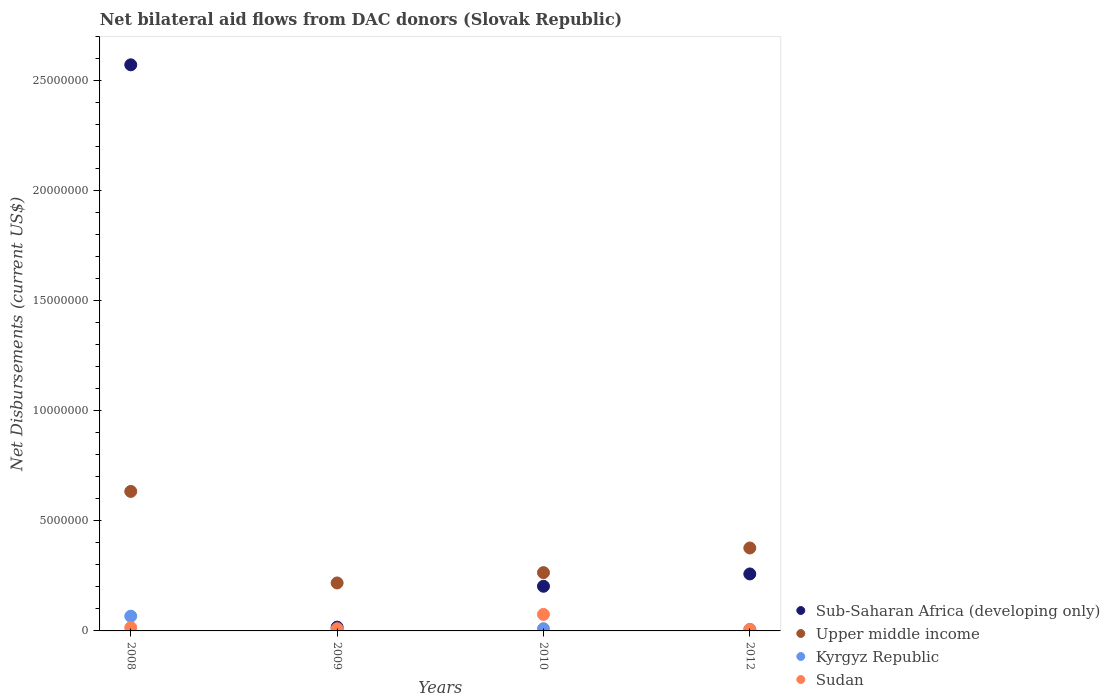What is the net bilateral aid flows in Kyrgyz Republic in 2008?
Offer a very short reply. 6.70e+05. Across all years, what is the maximum net bilateral aid flows in Kyrgyz Republic?
Ensure brevity in your answer.  6.70e+05. Across all years, what is the minimum net bilateral aid flows in Sub-Saharan Africa (developing only)?
Your answer should be compact. 1.70e+05. What is the total net bilateral aid flows in Sudan in the graph?
Offer a terse response. 1.06e+06. What is the difference between the net bilateral aid flows in Upper middle income in 2010 and that in 2012?
Provide a short and direct response. -1.12e+06. What is the difference between the net bilateral aid flows in Sudan in 2008 and the net bilateral aid flows in Sub-Saharan Africa (developing only) in 2012?
Provide a short and direct response. -2.44e+06. What is the average net bilateral aid flows in Sub-Saharan Africa (developing only) per year?
Keep it short and to the point. 7.63e+06. In the year 2008, what is the difference between the net bilateral aid flows in Sub-Saharan Africa (developing only) and net bilateral aid flows in Kyrgyz Republic?
Provide a succinct answer. 2.51e+07. What is the ratio of the net bilateral aid flows in Sudan in 2009 to that in 2010?
Make the answer very short. 0.13. Is the net bilateral aid flows in Kyrgyz Republic in 2009 less than that in 2012?
Provide a succinct answer. No. Is the difference between the net bilateral aid flows in Sub-Saharan Africa (developing only) in 2010 and 2012 greater than the difference between the net bilateral aid flows in Kyrgyz Republic in 2010 and 2012?
Your response must be concise. No. What is the difference between the highest and the second highest net bilateral aid flows in Kyrgyz Republic?
Give a very brief answer. 5.70e+05. What is the difference between the highest and the lowest net bilateral aid flows in Sudan?
Your response must be concise. 6.90e+05. Is it the case that in every year, the sum of the net bilateral aid flows in Sub-Saharan Africa (developing only) and net bilateral aid flows in Sudan  is greater than the sum of net bilateral aid flows in Kyrgyz Republic and net bilateral aid flows in Upper middle income?
Your response must be concise. Yes. Is it the case that in every year, the sum of the net bilateral aid flows in Upper middle income and net bilateral aid flows in Sudan  is greater than the net bilateral aid flows in Kyrgyz Republic?
Your response must be concise. Yes. Is the net bilateral aid flows in Sudan strictly less than the net bilateral aid flows in Sub-Saharan Africa (developing only) over the years?
Ensure brevity in your answer.  Yes. How many dotlines are there?
Keep it short and to the point. 4. How many years are there in the graph?
Offer a very short reply. 4. Are the values on the major ticks of Y-axis written in scientific E-notation?
Offer a terse response. No. Does the graph contain any zero values?
Your answer should be compact. No. Where does the legend appear in the graph?
Your answer should be very brief. Bottom right. How are the legend labels stacked?
Offer a terse response. Vertical. What is the title of the graph?
Offer a very short reply. Net bilateral aid flows from DAC donors (Slovak Republic). Does "Upper middle income" appear as one of the legend labels in the graph?
Make the answer very short. Yes. What is the label or title of the X-axis?
Provide a succinct answer. Years. What is the label or title of the Y-axis?
Ensure brevity in your answer.  Net Disbursements (current US$). What is the Net Disbursements (current US$) in Sub-Saharan Africa (developing only) in 2008?
Provide a succinct answer. 2.57e+07. What is the Net Disbursements (current US$) in Upper middle income in 2008?
Make the answer very short. 6.34e+06. What is the Net Disbursements (current US$) of Kyrgyz Republic in 2008?
Keep it short and to the point. 6.70e+05. What is the Net Disbursements (current US$) of Upper middle income in 2009?
Your answer should be very brief. 2.18e+06. What is the Net Disbursements (current US$) in Kyrgyz Republic in 2009?
Provide a succinct answer. 7.00e+04. What is the Net Disbursements (current US$) in Sub-Saharan Africa (developing only) in 2010?
Make the answer very short. 2.03e+06. What is the Net Disbursements (current US$) of Upper middle income in 2010?
Your response must be concise. 2.65e+06. What is the Net Disbursements (current US$) in Sudan in 2010?
Your response must be concise. 7.50e+05. What is the Net Disbursements (current US$) in Sub-Saharan Africa (developing only) in 2012?
Provide a succinct answer. 2.59e+06. What is the Net Disbursements (current US$) in Upper middle income in 2012?
Your answer should be very brief. 3.77e+06. What is the Net Disbursements (current US$) in Kyrgyz Republic in 2012?
Your answer should be compact. 7.00e+04. What is the Net Disbursements (current US$) of Sudan in 2012?
Ensure brevity in your answer.  6.00e+04. Across all years, what is the maximum Net Disbursements (current US$) of Sub-Saharan Africa (developing only)?
Your response must be concise. 2.57e+07. Across all years, what is the maximum Net Disbursements (current US$) in Upper middle income?
Provide a succinct answer. 6.34e+06. Across all years, what is the maximum Net Disbursements (current US$) in Kyrgyz Republic?
Provide a short and direct response. 6.70e+05. Across all years, what is the maximum Net Disbursements (current US$) of Sudan?
Keep it short and to the point. 7.50e+05. Across all years, what is the minimum Net Disbursements (current US$) in Sub-Saharan Africa (developing only)?
Make the answer very short. 1.70e+05. Across all years, what is the minimum Net Disbursements (current US$) of Upper middle income?
Give a very brief answer. 2.18e+06. What is the total Net Disbursements (current US$) of Sub-Saharan Africa (developing only) in the graph?
Your response must be concise. 3.05e+07. What is the total Net Disbursements (current US$) in Upper middle income in the graph?
Your answer should be compact. 1.49e+07. What is the total Net Disbursements (current US$) in Kyrgyz Republic in the graph?
Offer a terse response. 9.10e+05. What is the total Net Disbursements (current US$) in Sudan in the graph?
Your answer should be very brief. 1.06e+06. What is the difference between the Net Disbursements (current US$) in Sub-Saharan Africa (developing only) in 2008 and that in 2009?
Ensure brevity in your answer.  2.56e+07. What is the difference between the Net Disbursements (current US$) in Upper middle income in 2008 and that in 2009?
Offer a very short reply. 4.16e+06. What is the difference between the Net Disbursements (current US$) of Sub-Saharan Africa (developing only) in 2008 and that in 2010?
Your answer should be compact. 2.37e+07. What is the difference between the Net Disbursements (current US$) in Upper middle income in 2008 and that in 2010?
Your answer should be very brief. 3.69e+06. What is the difference between the Net Disbursements (current US$) of Kyrgyz Republic in 2008 and that in 2010?
Ensure brevity in your answer.  5.70e+05. What is the difference between the Net Disbursements (current US$) in Sudan in 2008 and that in 2010?
Your response must be concise. -6.00e+05. What is the difference between the Net Disbursements (current US$) of Sub-Saharan Africa (developing only) in 2008 and that in 2012?
Give a very brief answer. 2.31e+07. What is the difference between the Net Disbursements (current US$) in Upper middle income in 2008 and that in 2012?
Offer a very short reply. 2.57e+06. What is the difference between the Net Disbursements (current US$) of Kyrgyz Republic in 2008 and that in 2012?
Keep it short and to the point. 6.00e+05. What is the difference between the Net Disbursements (current US$) in Sudan in 2008 and that in 2012?
Provide a succinct answer. 9.00e+04. What is the difference between the Net Disbursements (current US$) in Sub-Saharan Africa (developing only) in 2009 and that in 2010?
Provide a succinct answer. -1.86e+06. What is the difference between the Net Disbursements (current US$) in Upper middle income in 2009 and that in 2010?
Offer a very short reply. -4.70e+05. What is the difference between the Net Disbursements (current US$) of Sudan in 2009 and that in 2010?
Offer a terse response. -6.50e+05. What is the difference between the Net Disbursements (current US$) of Sub-Saharan Africa (developing only) in 2009 and that in 2012?
Offer a very short reply. -2.42e+06. What is the difference between the Net Disbursements (current US$) of Upper middle income in 2009 and that in 2012?
Ensure brevity in your answer.  -1.59e+06. What is the difference between the Net Disbursements (current US$) in Sudan in 2009 and that in 2012?
Offer a very short reply. 4.00e+04. What is the difference between the Net Disbursements (current US$) of Sub-Saharan Africa (developing only) in 2010 and that in 2012?
Your response must be concise. -5.60e+05. What is the difference between the Net Disbursements (current US$) of Upper middle income in 2010 and that in 2012?
Give a very brief answer. -1.12e+06. What is the difference between the Net Disbursements (current US$) of Kyrgyz Republic in 2010 and that in 2012?
Your response must be concise. 3.00e+04. What is the difference between the Net Disbursements (current US$) in Sudan in 2010 and that in 2012?
Make the answer very short. 6.90e+05. What is the difference between the Net Disbursements (current US$) of Sub-Saharan Africa (developing only) in 2008 and the Net Disbursements (current US$) of Upper middle income in 2009?
Your answer should be compact. 2.36e+07. What is the difference between the Net Disbursements (current US$) in Sub-Saharan Africa (developing only) in 2008 and the Net Disbursements (current US$) in Kyrgyz Republic in 2009?
Your answer should be very brief. 2.57e+07. What is the difference between the Net Disbursements (current US$) in Sub-Saharan Africa (developing only) in 2008 and the Net Disbursements (current US$) in Sudan in 2009?
Your answer should be compact. 2.56e+07. What is the difference between the Net Disbursements (current US$) of Upper middle income in 2008 and the Net Disbursements (current US$) of Kyrgyz Republic in 2009?
Ensure brevity in your answer.  6.27e+06. What is the difference between the Net Disbursements (current US$) in Upper middle income in 2008 and the Net Disbursements (current US$) in Sudan in 2009?
Provide a succinct answer. 6.24e+06. What is the difference between the Net Disbursements (current US$) in Kyrgyz Republic in 2008 and the Net Disbursements (current US$) in Sudan in 2009?
Make the answer very short. 5.70e+05. What is the difference between the Net Disbursements (current US$) of Sub-Saharan Africa (developing only) in 2008 and the Net Disbursements (current US$) of Upper middle income in 2010?
Your response must be concise. 2.31e+07. What is the difference between the Net Disbursements (current US$) in Sub-Saharan Africa (developing only) in 2008 and the Net Disbursements (current US$) in Kyrgyz Republic in 2010?
Provide a short and direct response. 2.56e+07. What is the difference between the Net Disbursements (current US$) in Sub-Saharan Africa (developing only) in 2008 and the Net Disbursements (current US$) in Sudan in 2010?
Offer a very short reply. 2.50e+07. What is the difference between the Net Disbursements (current US$) of Upper middle income in 2008 and the Net Disbursements (current US$) of Kyrgyz Republic in 2010?
Make the answer very short. 6.24e+06. What is the difference between the Net Disbursements (current US$) of Upper middle income in 2008 and the Net Disbursements (current US$) of Sudan in 2010?
Make the answer very short. 5.59e+06. What is the difference between the Net Disbursements (current US$) in Kyrgyz Republic in 2008 and the Net Disbursements (current US$) in Sudan in 2010?
Give a very brief answer. -8.00e+04. What is the difference between the Net Disbursements (current US$) of Sub-Saharan Africa (developing only) in 2008 and the Net Disbursements (current US$) of Upper middle income in 2012?
Make the answer very short. 2.20e+07. What is the difference between the Net Disbursements (current US$) in Sub-Saharan Africa (developing only) in 2008 and the Net Disbursements (current US$) in Kyrgyz Republic in 2012?
Your response must be concise. 2.57e+07. What is the difference between the Net Disbursements (current US$) in Sub-Saharan Africa (developing only) in 2008 and the Net Disbursements (current US$) in Sudan in 2012?
Keep it short and to the point. 2.57e+07. What is the difference between the Net Disbursements (current US$) of Upper middle income in 2008 and the Net Disbursements (current US$) of Kyrgyz Republic in 2012?
Your answer should be compact. 6.27e+06. What is the difference between the Net Disbursements (current US$) in Upper middle income in 2008 and the Net Disbursements (current US$) in Sudan in 2012?
Your response must be concise. 6.28e+06. What is the difference between the Net Disbursements (current US$) of Sub-Saharan Africa (developing only) in 2009 and the Net Disbursements (current US$) of Upper middle income in 2010?
Make the answer very short. -2.48e+06. What is the difference between the Net Disbursements (current US$) of Sub-Saharan Africa (developing only) in 2009 and the Net Disbursements (current US$) of Kyrgyz Republic in 2010?
Ensure brevity in your answer.  7.00e+04. What is the difference between the Net Disbursements (current US$) of Sub-Saharan Africa (developing only) in 2009 and the Net Disbursements (current US$) of Sudan in 2010?
Your answer should be compact. -5.80e+05. What is the difference between the Net Disbursements (current US$) of Upper middle income in 2009 and the Net Disbursements (current US$) of Kyrgyz Republic in 2010?
Give a very brief answer. 2.08e+06. What is the difference between the Net Disbursements (current US$) in Upper middle income in 2009 and the Net Disbursements (current US$) in Sudan in 2010?
Provide a short and direct response. 1.43e+06. What is the difference between the Net Disbursements (current US$) in Kyrgyz Republic in 2009 and the Net Disbursements (current US$) in Sudan in 2010?
Give a very brief answer. -6.80e+05. What is the difference between the Net Disbursements (current US$) in Sub-Saharan Africa (developing only) in 2009 and the Net Disbursements (current US$) in Upper middle income in 2012?
Your answer should be compact. -3.60e+06. What is the difference between the Net Disbursements (current US$) in Sub-Saharan Africa (developing only) in 2009 and the Net Disbursements (current US$) in Kyrgyz Republic in 2012?
Ensure brevity in your answer.  1.00e+05. What is the difference between the Net Disbursements (current US$) in Sub-Saharan Africa (developing only) in 2009 and the Net Disbursements (current US$) in Sudan in 2012?
Keep it short and to the point. 1.10e+05. What is the difference between the Net Disbursements (current US$) in Upper middle income in 2009 and the Net Disbursements (current US$) in Kyrgyz Republic in 2012?
Offer a terse response. 2.11e+06. What is the difference between the Net Disbursements (current US$) in Upper middle income in 2009 and the Net Disbursements (current US$) in Sudan in 2012?
Your response must be concise. 2.12e+06. What is the difference between the Net Disbursements (current US$) of Sub-Saharan Africa (developing only) in 2010 and the Net Disbursements (current US$) of Upper middle income in 2012?
Offer a very short reply. -1.74e+06. What is the difference between the Net Disbursements (current US$) of Sub-Saharan Africa (developing only) in 2010 and the Net Disbursements (current US$) of Kyrgyz Republic in 2012?
Provide a succinct answer. 1.96e+06. What is the difference between the Net Disbursements (current US$) in Sub-Saharan Africa (developing only) in 2010 and the Net Disbursements (current US$) in Sudan in 2012?
Offer a terse response. 1.97e+06. What is the difference between the Net Disbursements (current US$) of Upper middle income in 2010 and the Net Disbursements (current US$) of Kyrgyz Republic in 2012?
Offer a terse response. 2.58e+06. What is the difference between the Net Disbursements (current US$) in Upper middle income in 2010 and the Net Disbursements (current US$) in Sudan in 2012?
Provide a succinct answer. 2.59e+06. What is the average Net Disbursements (current US$) of Sub-Saharan Africa (developing only) per year?
Offer a very short reply. 7.63e+06. What is the average Net Disbursements (current US$) of Upper middle income per year?
Your answer should be compact. 3.74e+06. What is the average Net Disbursements (current US$) of Kyrgyz Republic per year?
Give a very brief answer. 2.28e+05. What is the average Net Disbursements (current US$) in Sudan per year?
Ensure brevity in your answer.  2.65e+05. In the year 2008, what is the difference between the Net Disbursements (current US$) in Sub-Saharan Africa (developing only) and Net Disbursements (current US$) in Upper middle income?
Provide a succinct answer. 1.94e+07. In the year 2008, what is the difference between the Net Disbursements (current US$) of Sub-Saharan Africa (developing only) and Net Disbursements (current US$) of Kyrgyz Republic?
Give a very brief answer. 2.51e+07. In the year 2008, what is the difference between the Net Disbursements (current US$) of Sub-Saharan Africa (developing only) and Net Disbursements (current US$) of Sudan?
Provide a short and direct response. 2.56e+07. In the year 2008, what is the difference between the Net Disbursements (current US$) of Upper middle income and Net Disbursements (current US$) of Kyrgyz Republic?
Keep it short and to the point. 5.67e+06. In the year 2008, what is the difference between the Net Disbursements (current US$) of Upper middle income and Net Disbursements (current US$) of Sudan?
Your answer should be very brief. 6.19e+06. In the year 2008, what is the difference between the Net Disbursements (current US$) in Kyrgyz Republic and Net Disbursements (current US$) in Sudan?
Provide a succinct answer. 5.20e+05. In the year 2009, what is the difference between the Net Disbursements (current US$) in Sub-Saharan Africa (developing only) and Net Disbursements (current US$) in Upper middle income?
Make the answer very short. -2.01e+06. In the year 2009, what is the difference between the Net Disbursements (current US$) in Sub-Saharan Africa (developing only) and Net Disbursements (current US$) in Kyrgyz Republic?
Provide a succinct answer. 1.00e+05. In the year 2009, what is the difference between the Net Disbursements (current US$) in Sub-Saharan Africa (developing only) and Net Disbursements (current US$) in Sudan?
Provide a succinct answer. 7.00e+04. In the year 2009, what is the difference between the Net Disbursements (current US$) in Upper middle income and Net Disbursements (current US$) in Kyrgyz Republic?
Your answer should be very brief. 2.11e+06. In the year 2009, what is the difference between the Net Disbursements (current US$) in Upper middle income and Net Disbursements (current US$) in Sudan?
Give a very brief answer. 2.08e+06. In the year 2009, what is the difference between the Net Disbursements (current US$) of Kyrgyz Republic and Net Disbursements (current US$) of Sudan?
Your response must be concise. -3.00e+04. In the year 2010, what is the difference between the Net Disbursements (current US$) of Sub-Saharan Africa (developing only) and Net Disbursements (current US$) of Upper middle income?
Your response must be concise. -6.20e+05. In the year 2010, what is the difference between the Net Disbursements (current US$) of Sub-Saharan Africa (developing only) and Net Disbursements (current US$) of Kyrgyz Republic?
Ensure brevity in your answer.  1.93e+06. In the year 2010, what is the difference between the Net Disbursements (current US$) in Sub-Saharan Africa (developing only) and Net Disbursements (current US$) in Sudan?
Make the answer very short. 1.28e+06. In the year 2010, what is the difference between the Net Disbursements (current US$) in Upper middle income and Net Disbursements (current US$) in Kyrgyz Republic?
Keep it short and to the point. 2.55e+06. In the year 2010, what is the difference between the Net Disbursements (current US$) in Upper middle income and Net Disbursements (current US$) in Sudan?
Your answer should be very brief. 1.90e+06. In the year 2010, what is the difference between the Net Disbursements (current US$) in Kyrgyz Republic and Net Disbursements (current US$) in Sudan?
Your response must be concise. -6.50e+05. In the year 2012, what is the difference between the Net Disbursements (current US$) of Sub-Saharan Africa (developing only) and Net Disbursements (current US$) of Upper middle income?
Provide a short and direct response. -1.18e+06. In the year 2012, what is the difference between the Net Disbursements (current US$) in Sub-Saharan Africa (developing only) and Net Disbursements (current US$) in Kyrgyz Republic?
Provide a succinct answer. 2.52e+06. In the year 2012, what is the difference between the Net Disbursements (current US$) of Sub-Saharan Africa (developing only) and Net Disbursements (current US$) of Sudan?
Provide a short and direct response. 2.53e+06. In the year 2012, what is the difference between the Net Disbursements (current US$) in Upper middle income and Net Disbursements (current US$) in Kyrgyz Republic?
Offer a terse response. 3.70e+06. In the year 2012, what is the difference between the Net Disbursements (current US$) in Upper middle income and Net Disbursements (current US$) in Sudan?
Your response must be concise. 3.71e+06. In the year 2012, what is the difference between the Net Disbursements (current US$) in Kyrgyz Republic and Net Disbursements (current US$) in Sudan?
Ensure brevity in your answer.  10000. What is the ratio of the Net Disbursements (current US$) of Sub-Saharan Africa (developing only) in 2008 to that in 2009?
Provide a succinct answer. 151.35. What is the ratio of the Net Disbursements (current US$) of Upper middle income in 2008 to that in 2009?
Offer a very short reply. 2.91. What is the ratio of the Net Disbursements (current US$) in Kyrgyz Republic in 2008 to that in 2009?
Your answer should be compact. 9.57. What is the ratio of the Net Disbursements (current US$) of Sub-Saharan Africa (developing only) in 2008 to that in 2010?
Provide a short and direct response. 12.67. What is the ratio of the Net Disbursements (current US$) of Upper middle income in 2008 to that in 2010?
Your answer should be very brief. 2.39. What is the ratio of the Net Disbursements (current US$) of Kyrgyz Republic in 2008 to that in 2010?
Provide a succinct answer. 6.7. What is the ratio of the Net Disbursements (current US$) of Sub-Saharan Africa (developing only) in 2008 to that in 2012?
Keep it short and to the point. 9.93. What is the ratio of the Net Disbursements (current US$) in Upper middle income in 2008 to that in 2012?
Provide a short and direct response. 1.68. What is the ratio of the Net Disbursements (current US$) of Kyrgyz Republic in 2008 to that in 2012?
Give a very brief answer. 9.57. What is the ratio of the Net Disbursements (current US$) in Sudan in 2008 to that in 2012?
Provide a short and direct response. 2.5. What is the ratio of the Net Disbursements (current US$) in Sub-Saharan Africa (developing only) in 2009 to that in 2010?
Provide a short and direct response. 0.08. What is the ratio of the Net Disbursements (current US$) in Upper middle income in 2009 to that in 2010?
Make the answer very short. 0.82. What is the ratio of the Net Disbursements (current US$) of Sudan in 2009 to that in 2010?
Make the answer very short. 0.13. What is the ratio of the Net Disbursements (current US$) in Sub-Saharan Africa (developing only) in 2009 to that in 2012?
Give a very brief answer. 0.07. What is the ratio of the Net Disbursements (current US$) in Upper middle income in 2009 to that in 2012?
Keep it short and to the point. 0.58. What is the ratio of the Net Disbursements (current US$) of Kyrgyz Republic in 2009 to that in 2012?
Keep it short and to the point. 1. What is the ratio of the Net Disbursements (current US$) in Sub-Saharan Africa (developing only) in 2010 to that in 2012?
Make the answer very short. 0.78. What is the ratio of the Net Disbursements (current US$) in Upper middle income in 2010 to that in 2012?
Provide a succinct answer. 0.7. What is the ratio of the Net Disbursements (current US$) in Kyrgyz Republic in 2010 to that in 2012?
Provide a short and direct response. 1.43. What is the ratio of the Net Disbursements (current US$) of Sudan in 2010 to that in 2012?
Provide a succinct answer. 12.5. What is the difference between the highest and the second highest Net Disbursements (current US$) of Sub-Saharan Africa (developing only)?
Your answer should be very brief. 2.31e+07. What is the difference between the highest and the second highest Net Disbursements (current US$) in Upper middle income?
Your answer should be very brief. 2.57e+06. What is the difference between the highest and the second highest Net Disbursements (current US$) of Kyrgyz Republic?
Offer a very short reply. 5.70e+05. What is the difference between the highest and the second highest Net Disbursements (current US$) in Sudan?
Keep it short and to the point. 6.00e+05. What is the difference between the highest and the lowest Net Disbursements (current US$) in Sub-Saharan Africa (developing only)?
Offer a terse response. 2.56e+07. What is the difference between the highest and the lowest Net Disbursements (current US$) of Upper middle income?
Offer a very short reply. 4.16e+06. What is the difference between the highest and the lowest Net Disbursements (current US$) in Sudan?
Keep it short and to the point. 6.90e+05. 